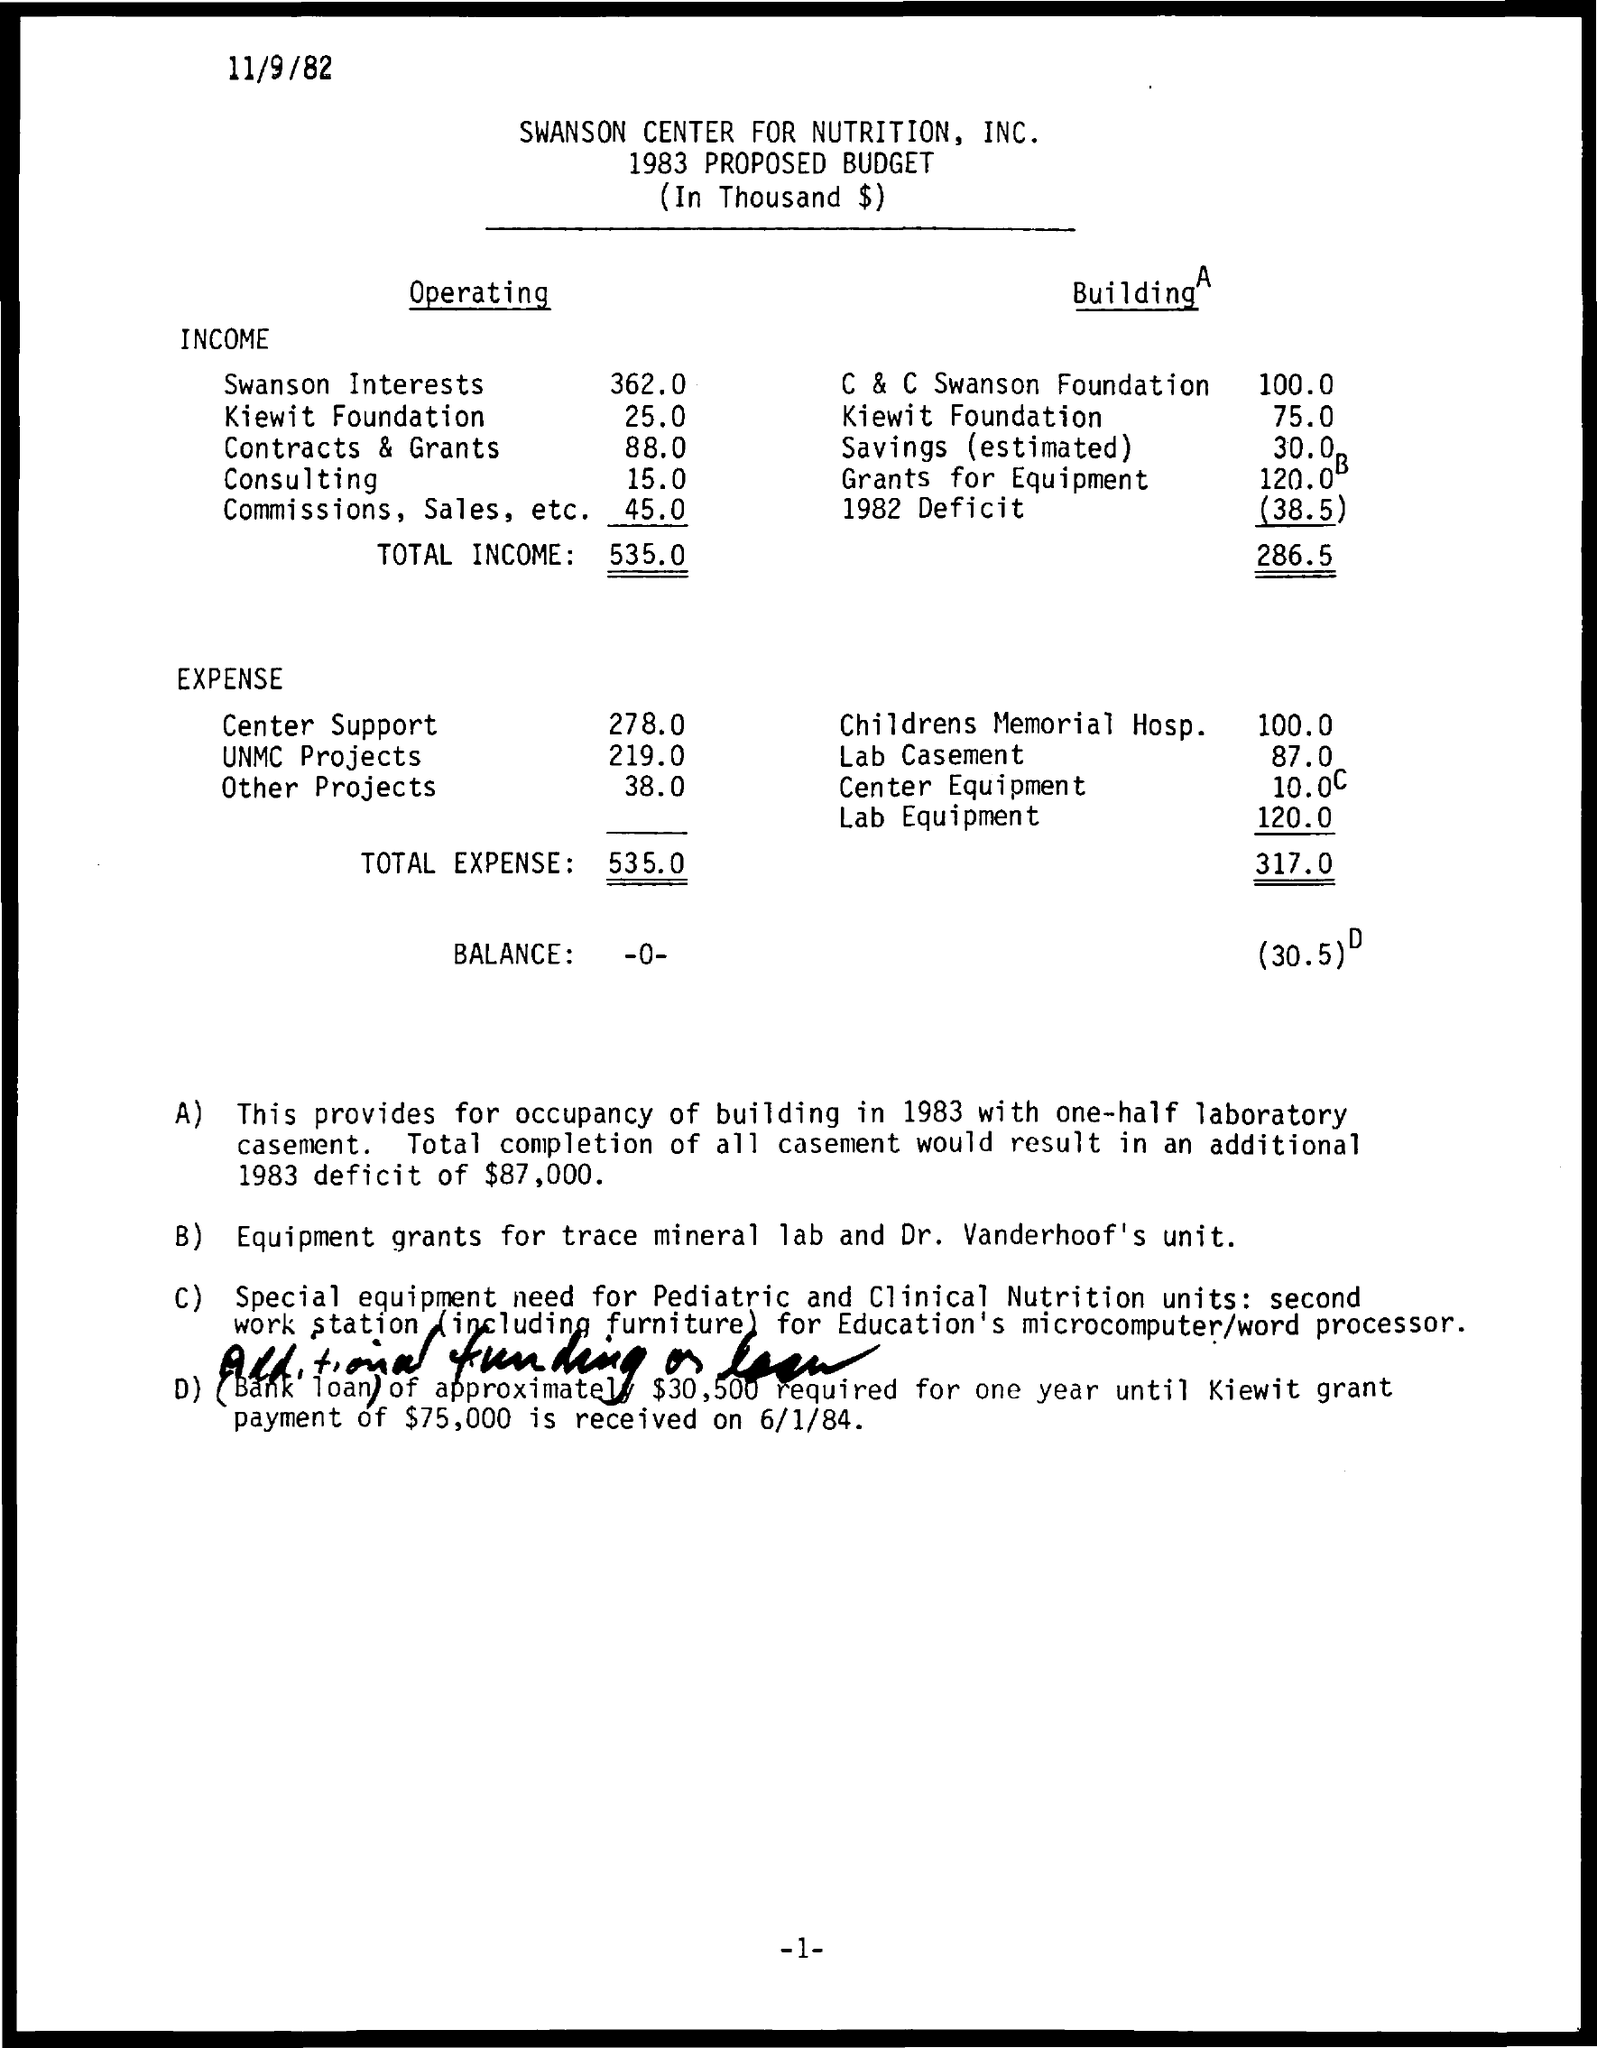What is the date given at the left top of the document?
Give a very brief answer. 11/9/82. What is the name of "CENTER FOR NUTRITION"?
Offer a very short reply. Swanson. "PROPOSED BUDGET" of which year is given?
Provide a short and direct response. 1983. What is the first subheading under the heading "Operating"?
Give a very brief answer. INCOME. What is the second subheading under the heading "Operating"?
Give a very brief answer. EXPENSE. What is the "Operating" INCOME of "Swanson Interests"?
Give a very brief answer. 362.0. What is the "Operating" INCOME of "Kiewit Foundation"?
Give a very brief answer. 25.0. What is the "TOTAL INCOME" under  "Operating" subheading?
Ensure brevity in your answer.  535.0. What is the "Center Support" EXPENSE?
Offer a very short reply. 278.0. What is the EXPENSE for "UNMC Projects"?
Keep it short and to the point. 219.0. What is the "TOTAL EXPENSE" under "Operating" subheading?
Keep it short and to the point. 535.0. Total completion of all casement would result in an additional 1983 deficit of what amount?
Provide a succinct answer. Total completion of all casement would result in an additional 1983 deficit of $87,000. 